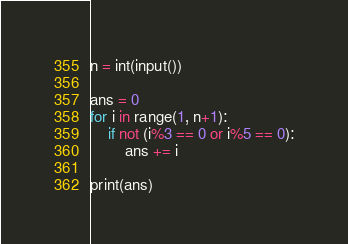<code> <loc_0><loc_0><loc_500><loc_500><_Python_>n = int(input())

ans = 0
for i in range(1, n+1):
    if not (i%3 == 0 or i%5 == 0):
        ans += i

print(ans)</code> 